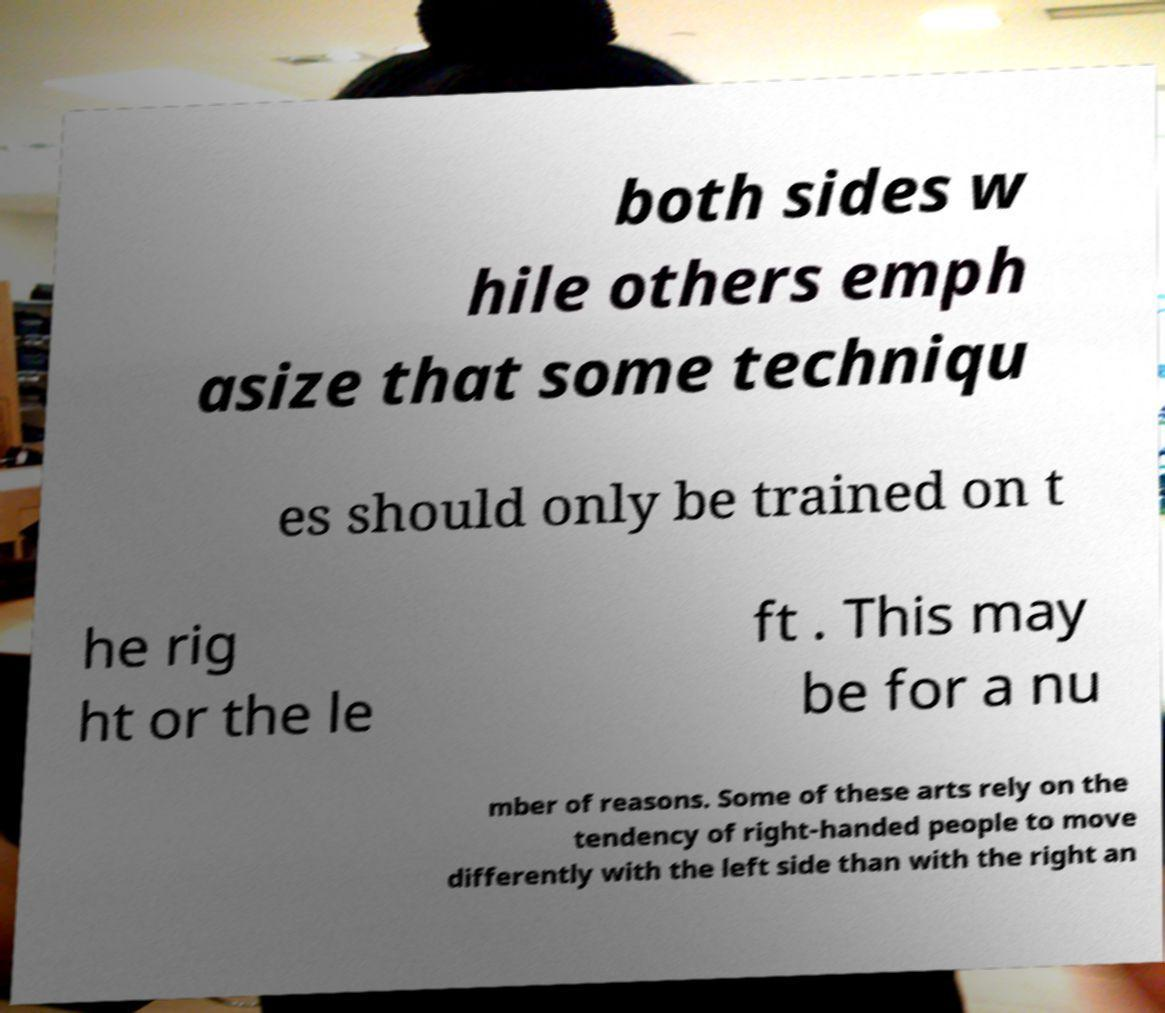Please read and relay the text visible in this image. What does it say? both sides w hile others emph asize that some techniqu es should only be trained on t he rig ht or the le ft . This may be for a nu mber of reasons. Some of these arts rely on the tendency of right-handed people to move differently with the left side than with the right an 